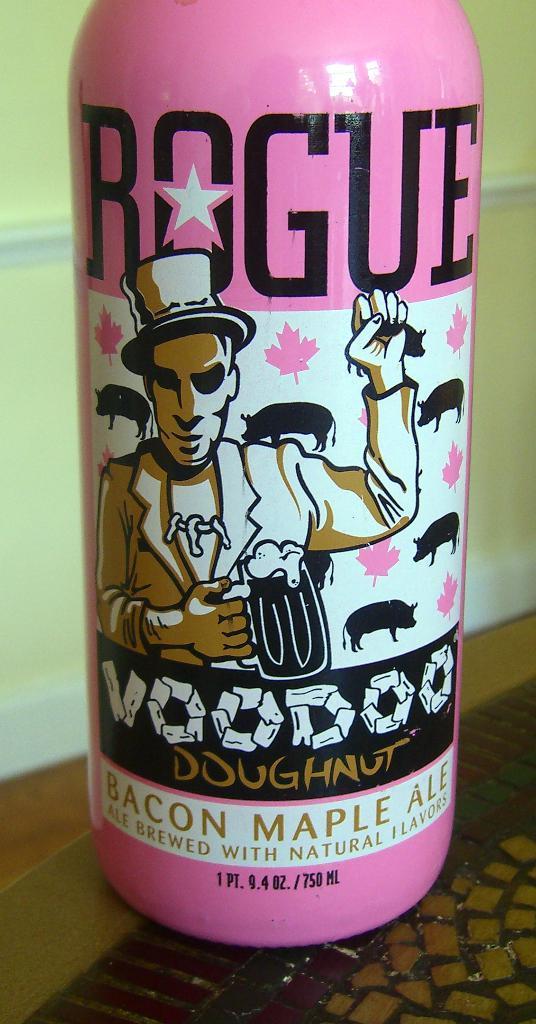How would you summarize this image in a sentence or two? Here in this picture we can see a pink colored bottle present over there and on that we can see some printing done over there. 